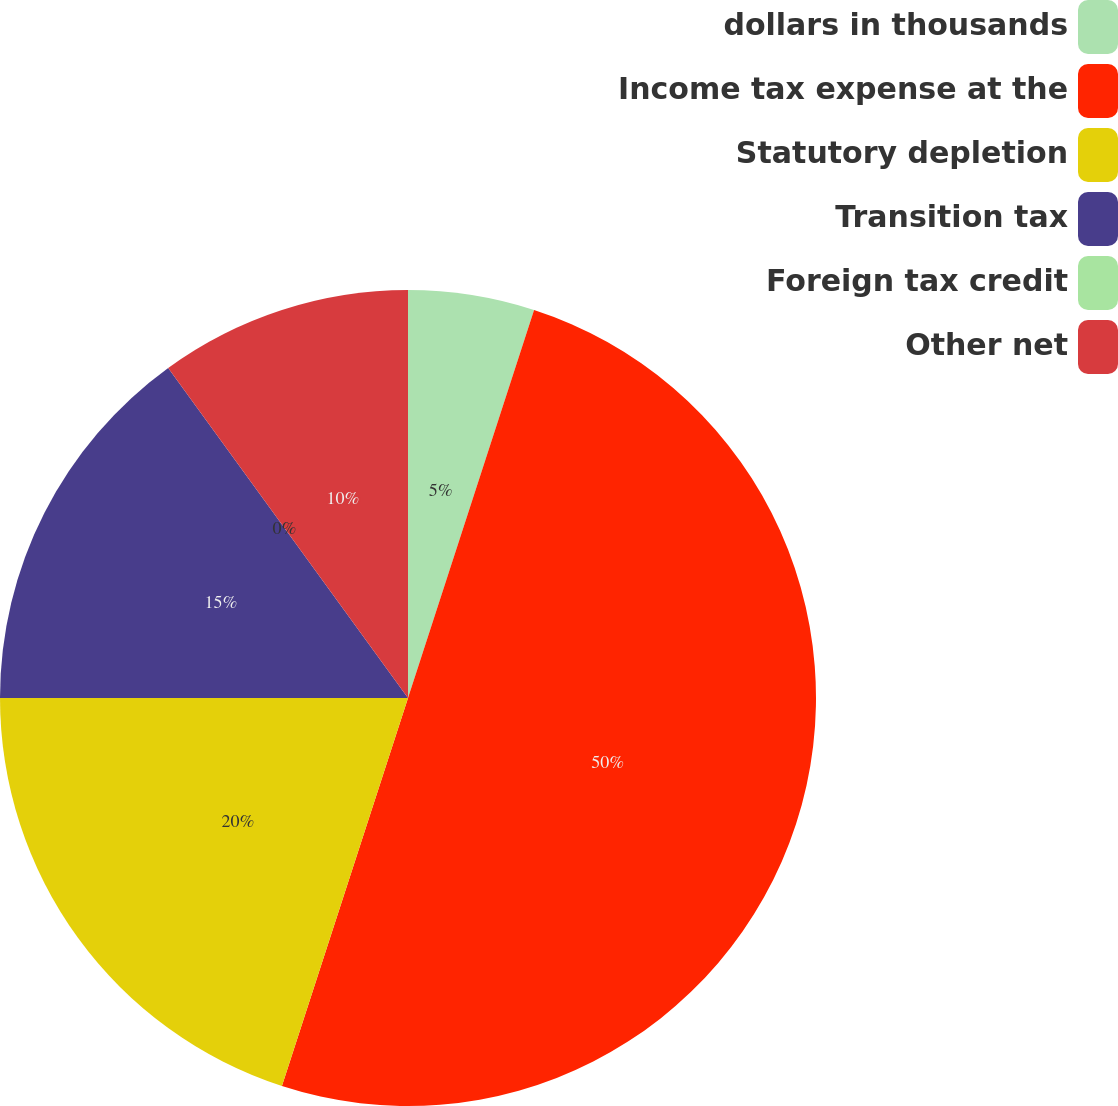<chart> <loc_0><loc_0><loc_500><loc_500><pie_chart><fcel>dollars in thousands<fcel>Income tax expense at the<fcel>Statutory depletion<fcel>Transition tax<fcel>Foreign tax credit<fcel>Other net<nl><fcel>5.0%<fcel>50.0%<fcel>20.0%<fcel>15.0%<fcel>0.0%<fcel>10.0%<nl></chart> 